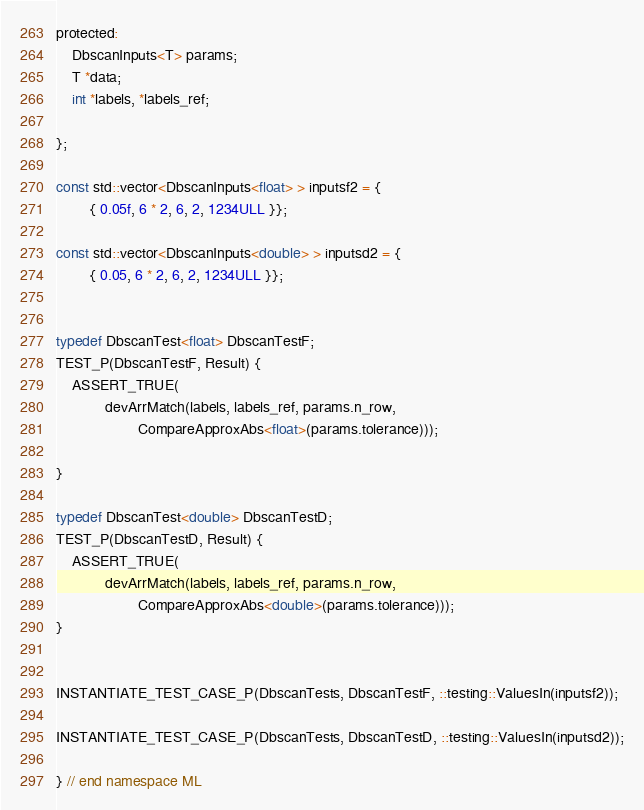Convert code to text. <code><loc_0><loc_0><loc_500><loc_500><_Cuda_>
protected:
	DbscanInputs<T> params;
	T *data;
	int *labels, *labels_ref;

};

const std::vector<DbscanInputs<float> > inputsf2 = {
		{ 0.05f, 6 * 2, 6, 2, 1234ULL }};

const std::vector<DbscanInputs<double> > inputsd2 = {
		{ 0.05, 6 * 2, 6, 2, 1234ULL }};


typedef DbscanTest<float> DbscanTestF;
TEST_P(DbscanTestF, Result) {
	ASSERT_TRUE(
			devArrMatch(labels, labels_ref, params.n_row,
					CompareApproxAbs<float>(params.tolerance)));

}

typedef DbscanTest<double> DbscanTestD;
TEST_P(DbscanTestD, Result) {
	ASSERT_TRUE(
			devArrMatch(labels, labels_ref, params.n_row,
					CompareApproxAbs<double>(params.tolerance)));
}


INSTANTIATE_TEST_CASE_P(DbscanTests, DbscanTestF, ::testing::ValuesIn(inputsf2));

INSTANTIATE_TEST_CASE_P(DbscanTests, DbscanTestD, ::testing::ValuesIn(inputsd2));

} // end namespace ML
</code> 